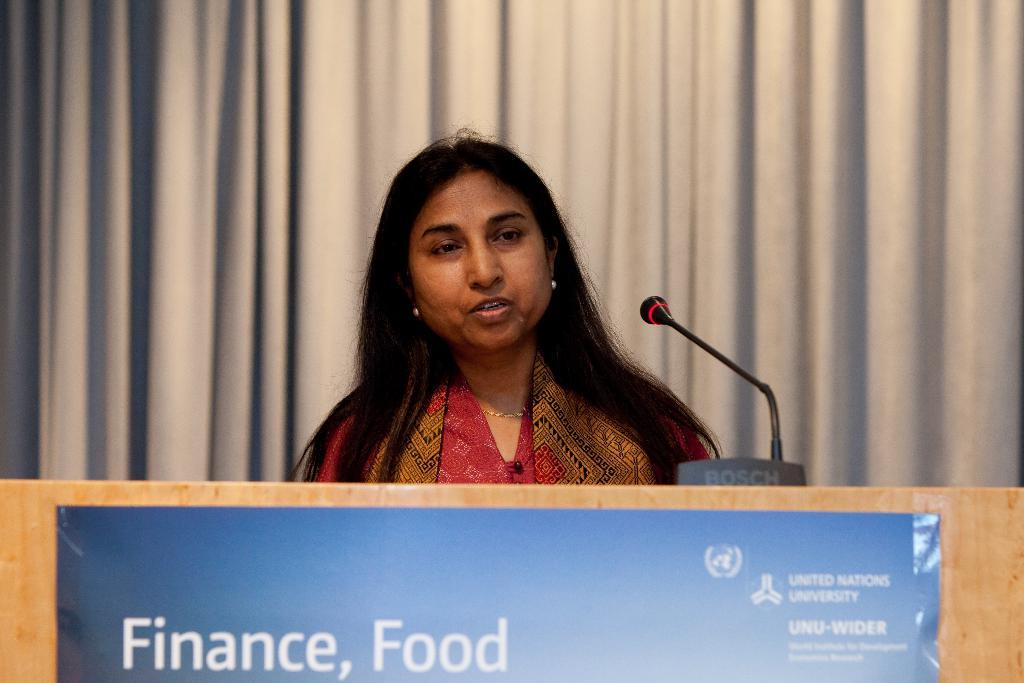Who is present in the image? There is a lady in the image. What object can be seen in front of the lady? There is a podium in the image. What is written on the poster in the image? There is a poster with text in the image. What device is used for amplifying sound in the image? There is a microphone in the image. What type of background element is visible in the image? There is a curtain in the background of the image. Where is the zoo located in the image? There is no zoo present in the image. What type of net is used to catch the lady's nerves in the image? There is no net or mention of nerves in the image; it features a lady, a podium, a poster, a microphone, and a curtain. 